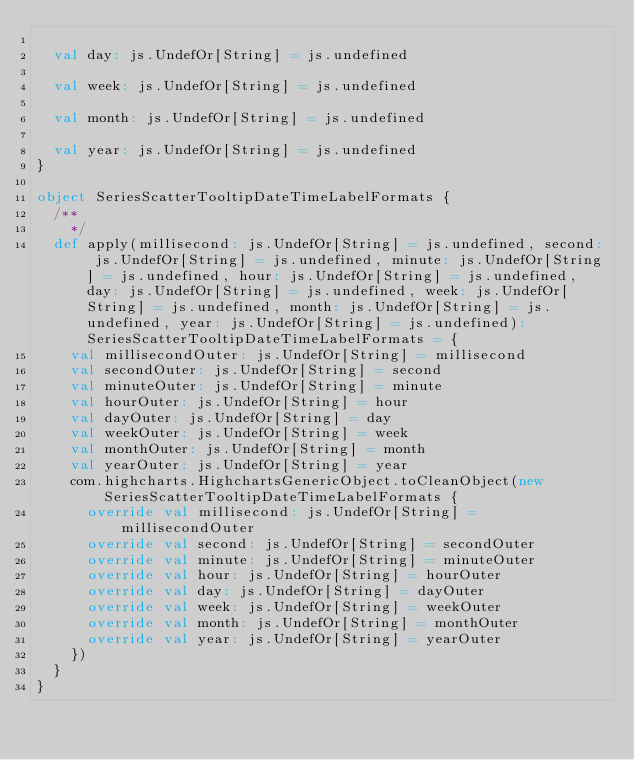Convert code to text. <code><loc_0><loc_0><loc_500><loc_500><_Scala_>
  val day: js.UndefOr[String] = js.undefined

  val week: js.UndefOr[String] = js.undefined

  val month: js.UndefOr[String] = js.undefined

  val year: js.UndefOr[String] = js.undefined
}

object SeriesScatterTooltipDateTimeLabelFormats {
  /**
    */
  def apply(millisecond: js.UndefOr[String] = js.undefined, second: js.UndefOr[String] = js.undefined, minute: js.UndefOr[String] = js.undefined, hour: js.UndefOr[String] = js.undefined, day: js.UndefOr[String] = js.undefined, week: js.UndefOr[String] = js.undefined, month: js.UndefOr[String] = js.undefined, year: js.UndefOr[String] = js.undefined): SeriesScatterTooltipDateTimeLabelFormats = {
    val millisecondOuter: js.UndefOr[String] = millisecond
    val secondOuter: js.UndefOr[String] = second
    val minuteOuter: js.UndefOr[String] = minute
    val hourOuter: js.UndefOr[String] = hour
    val dayOuter: js.UndefOr[String] = day
    val weekOuter: js.UndefOr[String] = week
    val monthOuter: js.UndefOr[String] = month
    val yearOuter: js.UndefOr[String] = year
    com.highcharts.HighchartsGenericObject.toCleanObject(new SeriesScatterTooltipDateTimeLabelFormats {
      override val millisecond: js.UndefOr[String] = millisecondOuter
      override val second: js.UndefOr[String] = secondOuter
      override val minute: js.UndefOr[String] = minuteOuter
      override val hour: js.UndefOr[String] = hourOuter
      override val day: js.UndefOr[String] = dayOuter
      override val week: js.UndefOr[String] = weekOuter
      override val month: js.UndefOr[String] = monthOuter
      override val year: js.UndefOr[String] = yearOuter
    })
  }
}
</code> 